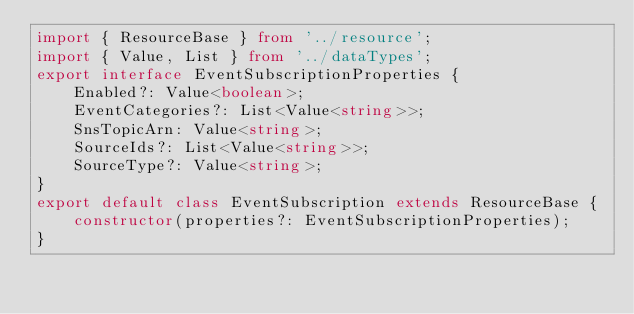<code> <loc_0><loc_0><loc_500><loc_500><_TypeScript_>import { ResourceBase } from '../resource';
import { Value, List } from '../dataTypes';
export interface EventSubscriptionProperties {
    Enabled?: Value<boolean>;
    EventCategories?: List<Value<string>>;
    SnsTopicArn: Value<string>;
    SourceIds?: List<Value<string>>;
    SourceType?: Value<string>;
}
export default class EventSubscription extends ResourceBase {
    constructor(properties?: EventSubscriptionProperties);
}
</code> 